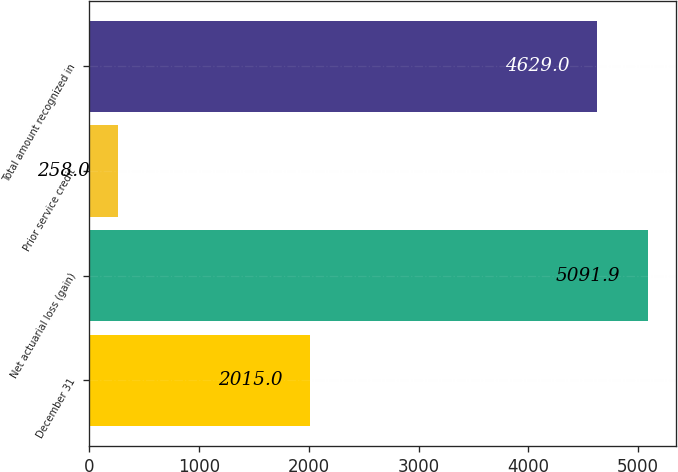Convert chart to OTSL. <chart><loc_0><loc_0><loc_500><loc_500><bar_chart><fcel>December 31<fcel>Net actuarial loss (gain)<fcel>Prior service credit<fcel>Total amount recognized in<nl><fcel>2015<fcel>5091.9<fcel>258<fcel>4629<nl></chart> 